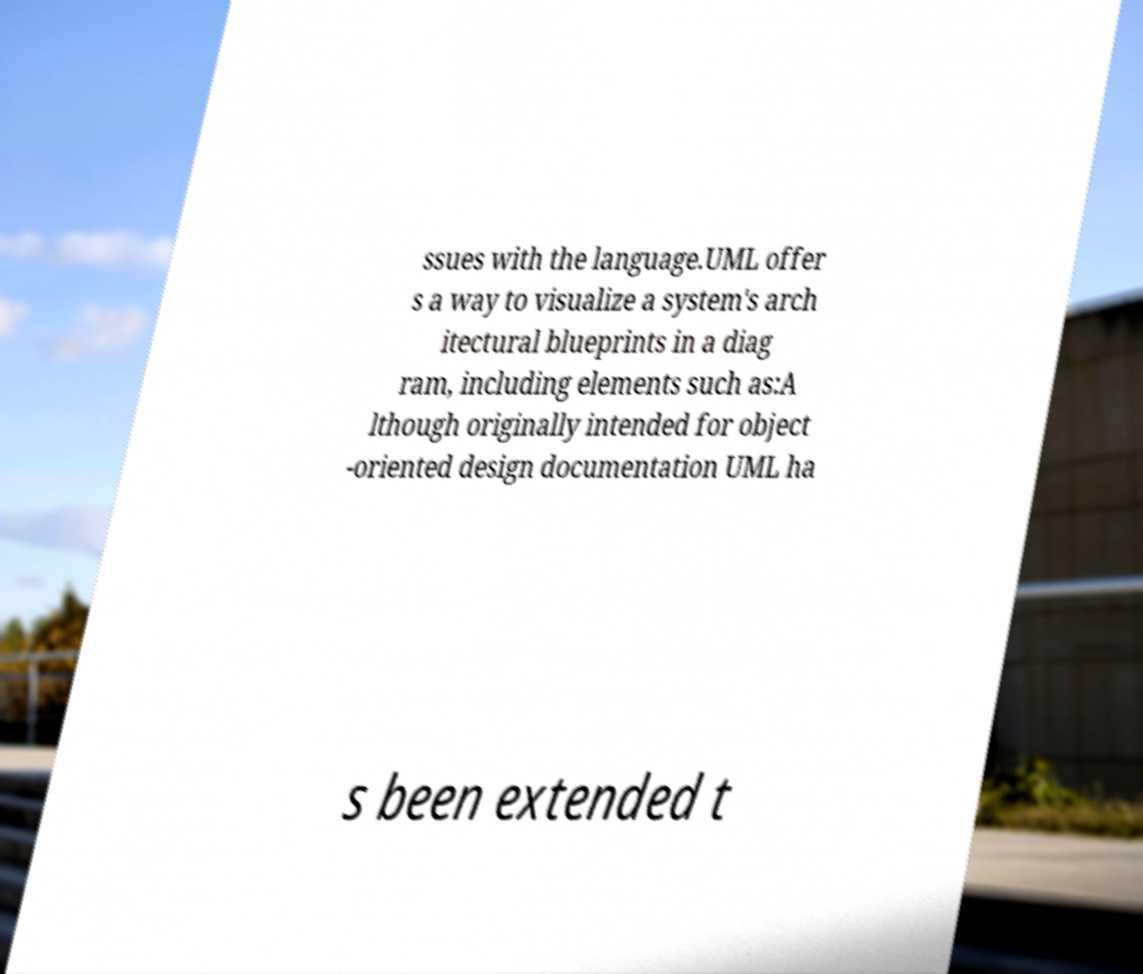Please identify and transcribe the text found in this image. ssues with the language.UML offer s a way to visualize a system's arch itectural blueprints in a diag ram, including elements such as:A lthough originally intended for object -oriented design documentation UML ha s been extended t 